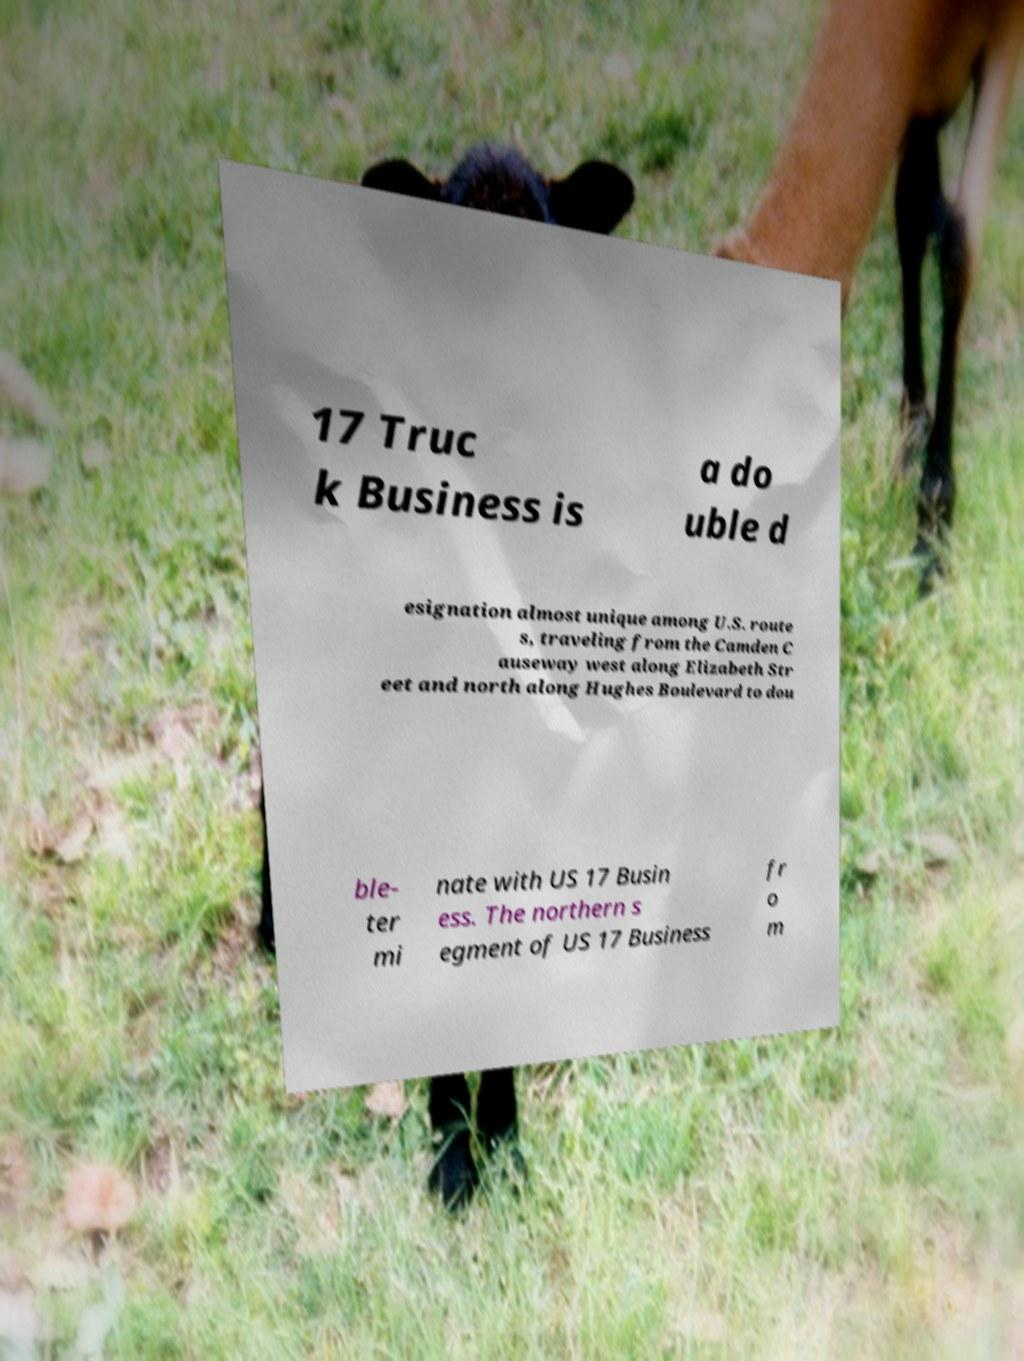Can you read and provide the text displayed in the image?This photo seems to have some interesting text. Can you extract and type it out for me? 17 Truc k Business is a do uble d esignation almost unique among U.S. route s, traveling from the Camden C auseway west along Elizabeth Str eet and north along Hughes Boulevard to dou ble- ter mi nate with US 17 Busin ess. The northern s egment of US 17 Business fr o m 